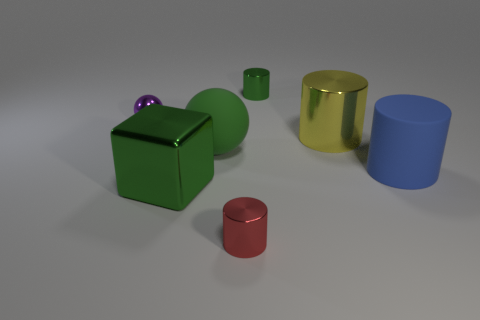What might the relative sizes of these objects tell us about their potential use? The various sizes of these objects may suggest they are educational tools designed to help with size differentiation and visual perception, or they could be simple geometric shapes used for decorative purposes. 